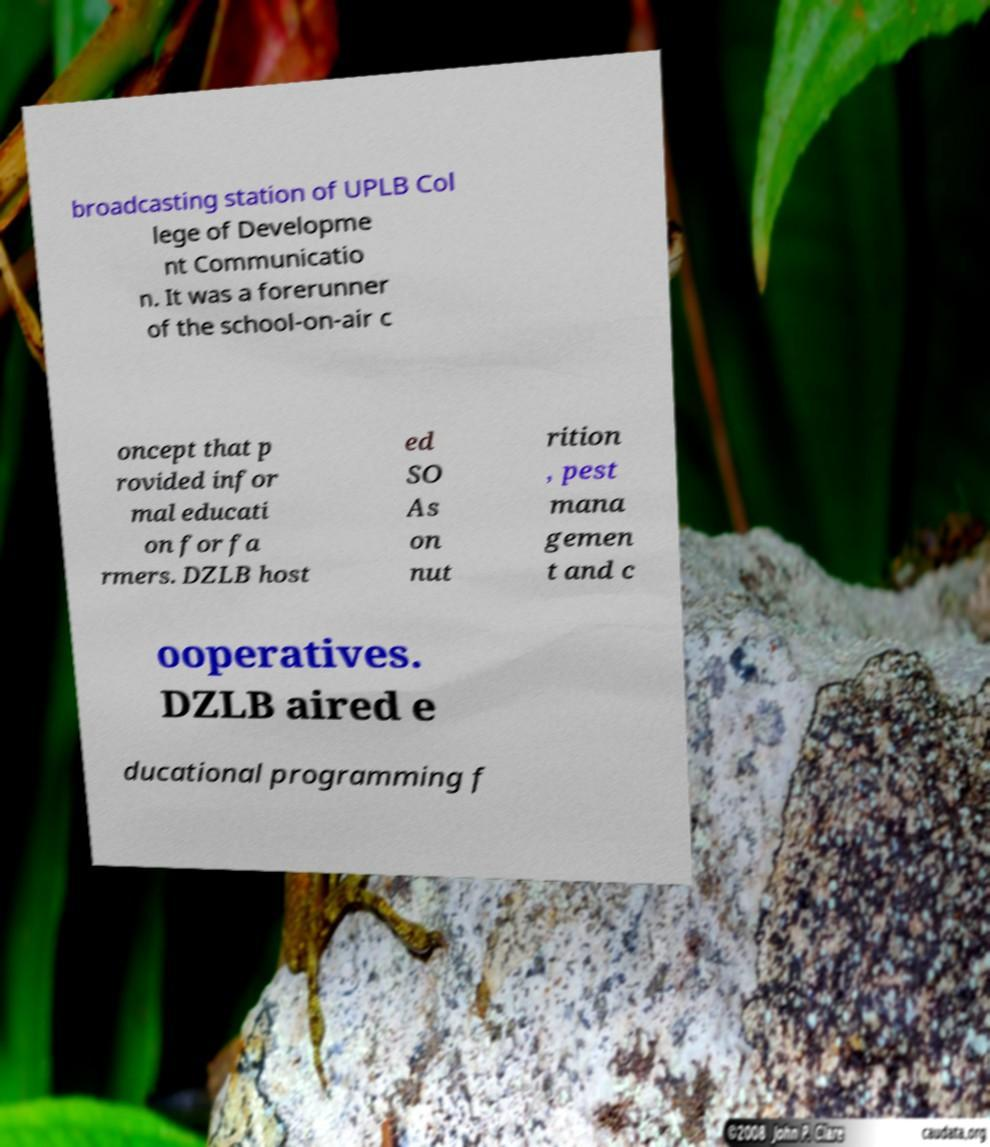Please read and relay the text visible in this image. What does it say? broadcasting station of UPLB Col lege of Developme nt Communicatio n. It was a forerunner of the school-on-air c oncept that p rovided infor mal educati on for fa rmers. DZLB host ed SO As on nut rition , pest mana gemen t and c ooperatives. DZLB aired e ducational programming f 